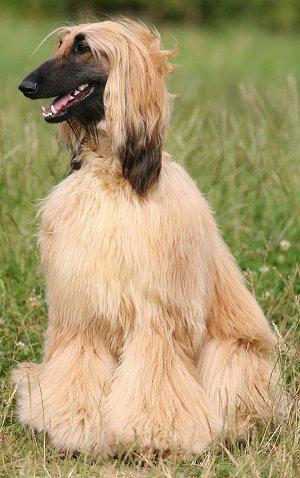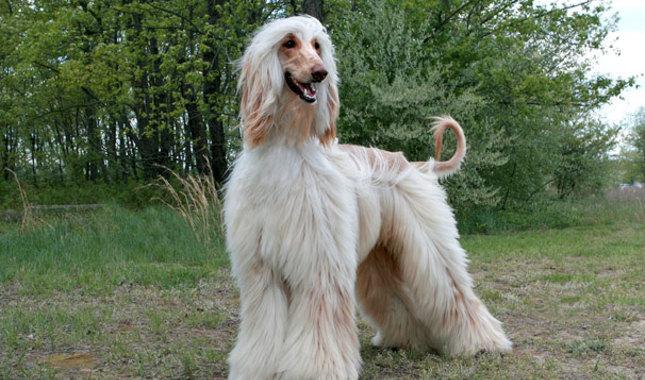The first image is the image on the left, the second image is the image on the right. Considering the images on both sides, is "There is at least one dog sitting in the image on the left" valid? Answer yes or no. Yes. The first image is the image on the left, the second image is the image on the right. Examine the images to the left and right. Is the description "An image shows exactly one hound standing still outdoors." accurate? Answer yes or no. Yes. 